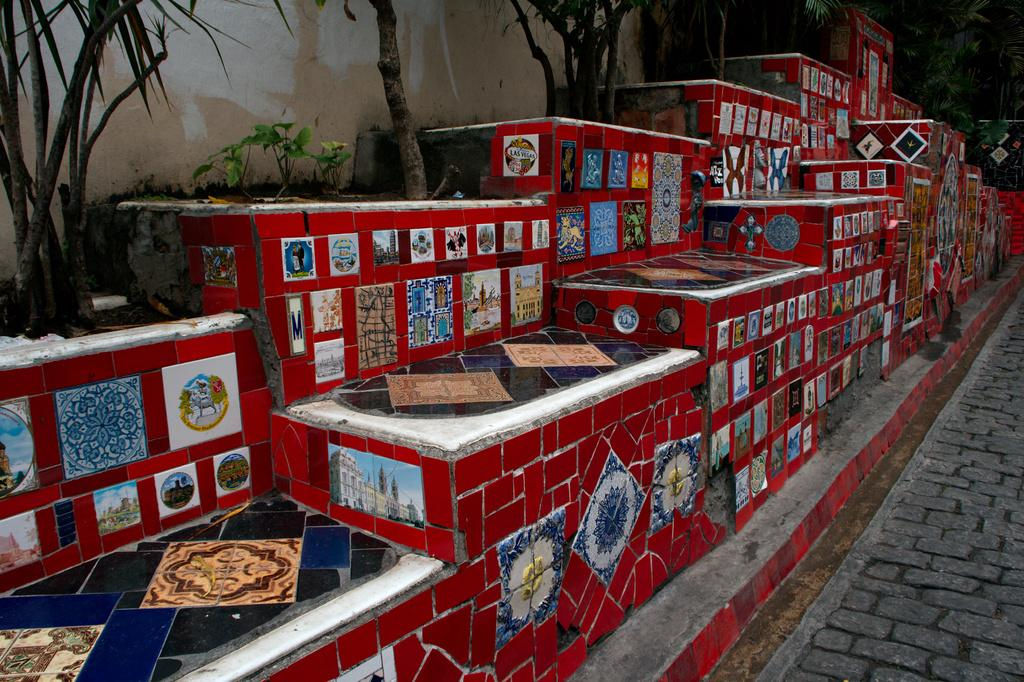What type of structure is present in the image? There is a concrete structure in the image. What design element is featured on the concrete structure? The concrete structure has colorful tiles. What type of surface is visible in the image? There is ground visible in the image. What type of vegetation is present in the image? There are trees in the image, and they are green in color. What color is the wall visible in the image? There is a cream-colored wall in the image. What type of jellyfish can be seen swimming in the image? There are no jellyfish present in the image; it features a concrete structure with colorful tiles, ground, trees, and a cream-colored wall. What question is being asked in the image? There is no question being asked in the image; it is a visual representation of a concrete structure, ground, trees, and a wall. 